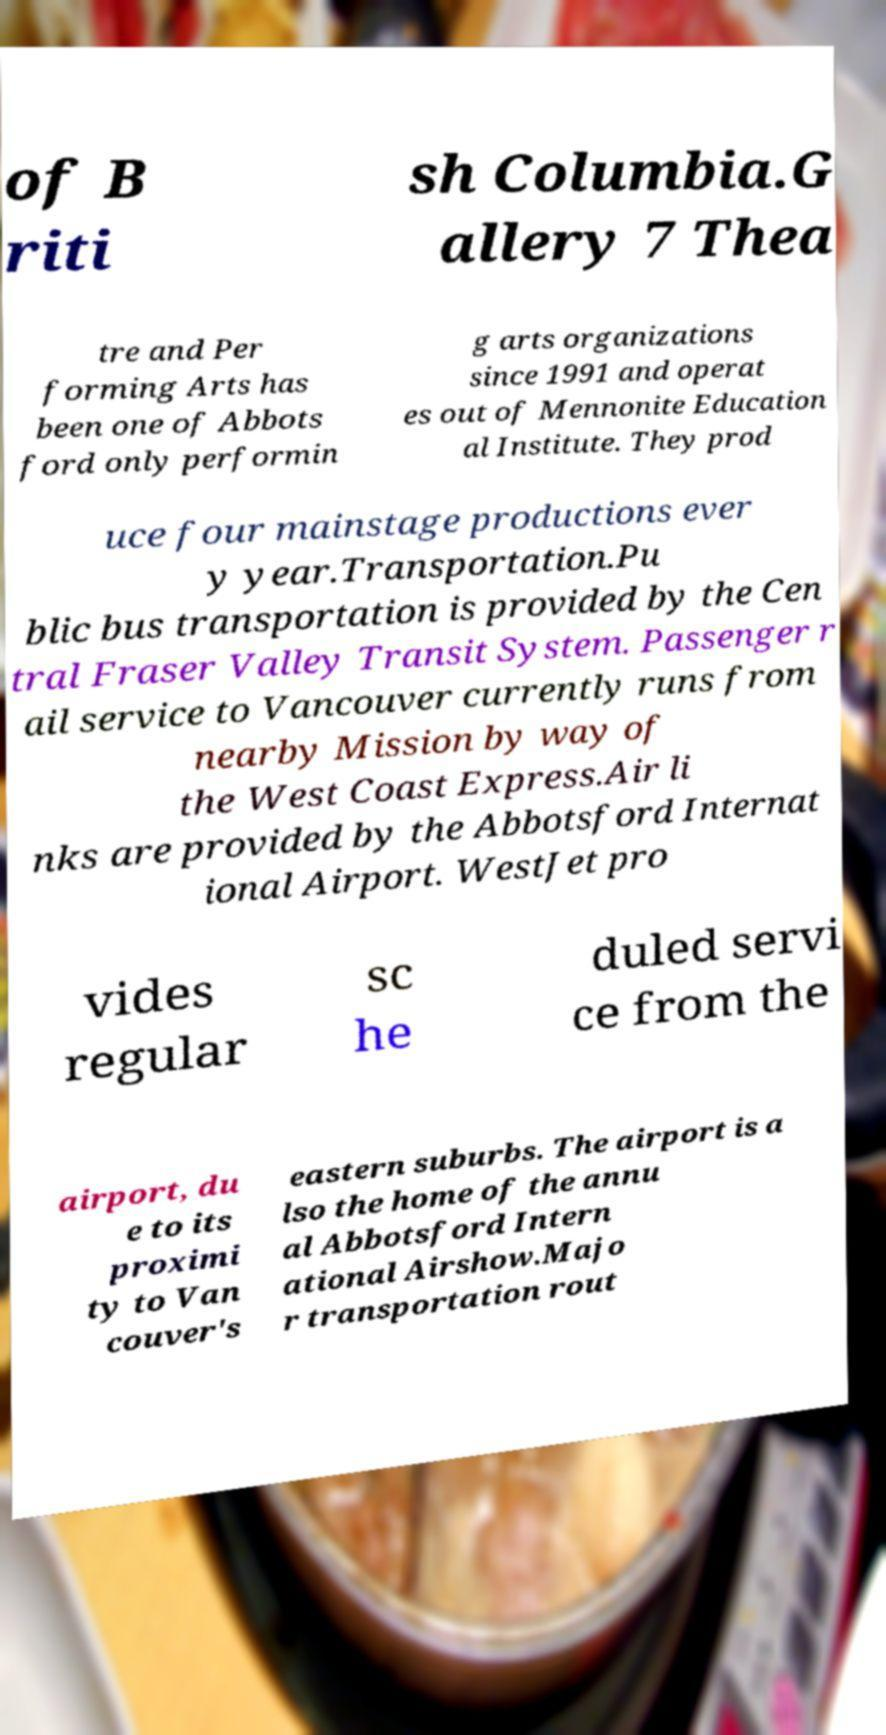Please read and relay the text visible in this image. What does it say? of B riti sh Columbia.G allery 7 Thea tre and Per forming Arts has been one of Abbots ford only performin g arts organizations since 1991 and operat es out of Mennonite Education al Institute. They prod uce four mainstage productions ever y year.Transportation.Pu blic bus transportation is provided by the Cen tral Fraser Valley Transit System. Passenger r ail service to Vancouver currently runs from nearby Mission by way of the West Coast Express.Air li nks are provided by the Abbotsford Internat ional Airport. WestJet pro vides regular sc he duled servi ce from the airport, du e to its proximi ty to Van couver's eastern suburbs. The airport is a lso the home of the annu al Abbotsford Intern ational Airshow.Majo r transportation rout 